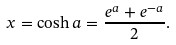<formula> <loc_0><loc_0><loc_500><loc_500>x = \cosh a = { \frac { e ^ { a } + e ^ { - a } } { 2 } } .</formula> 